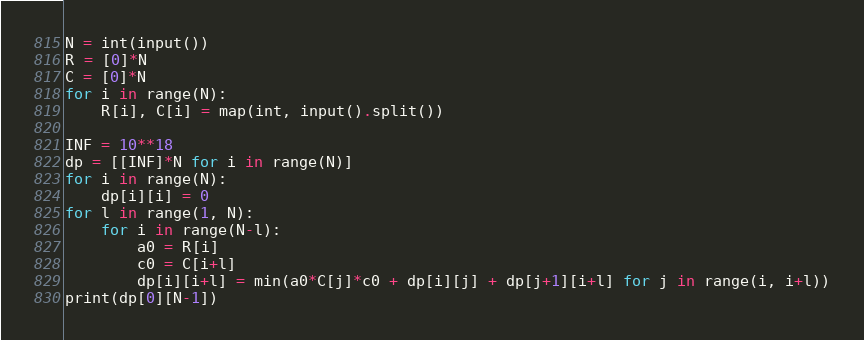<code> <loc_0><loc_0><loc_500><loc_500><_Python_>N = int(input())
R = [0]*N
C = [0]*N
for i in range(N):
    R[i], C[i] = map(int, input().split())

INF = 10**18
dp = [[INF]*N for i in range(N)]
for i in range(N):
    dp[i][i] = 0
for l in range(1, N):
    for i in range(N-l):
        a0 = R[i]
        c0 = C[i+l]
        dp[i][i+l] = min(a0*C[j]*c0 + dp[i][j] + dp[j+1][i+l] for j in range(i, i+l))
print(dp[0][N-1])

</code> 